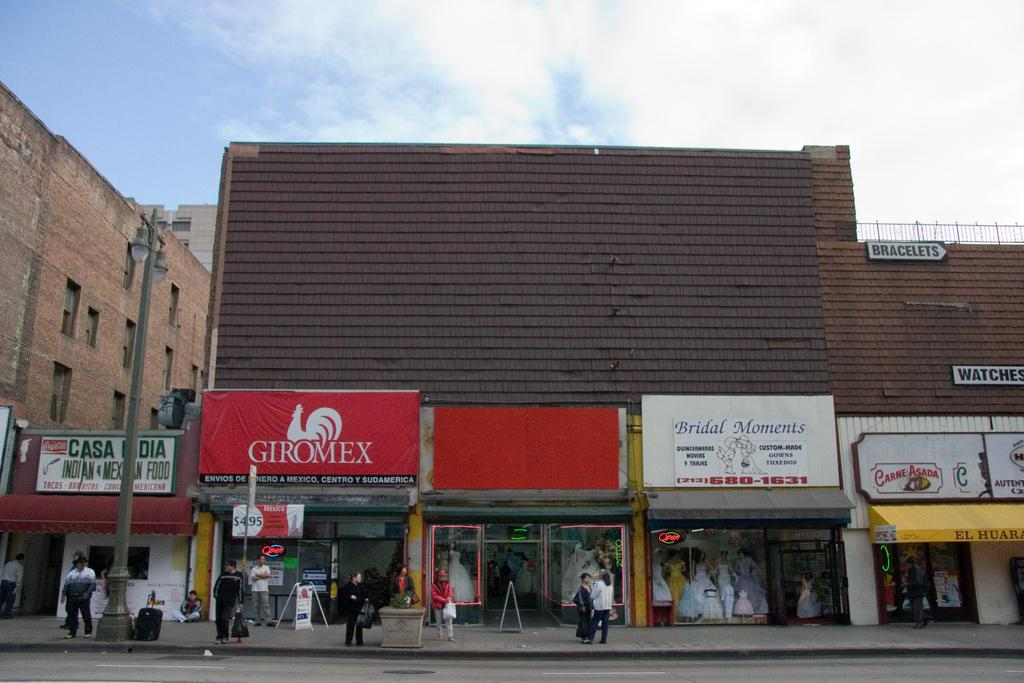<image>
Provide a brief description of the given image. A street scene with a sign bearing a rooster and the word giromex 